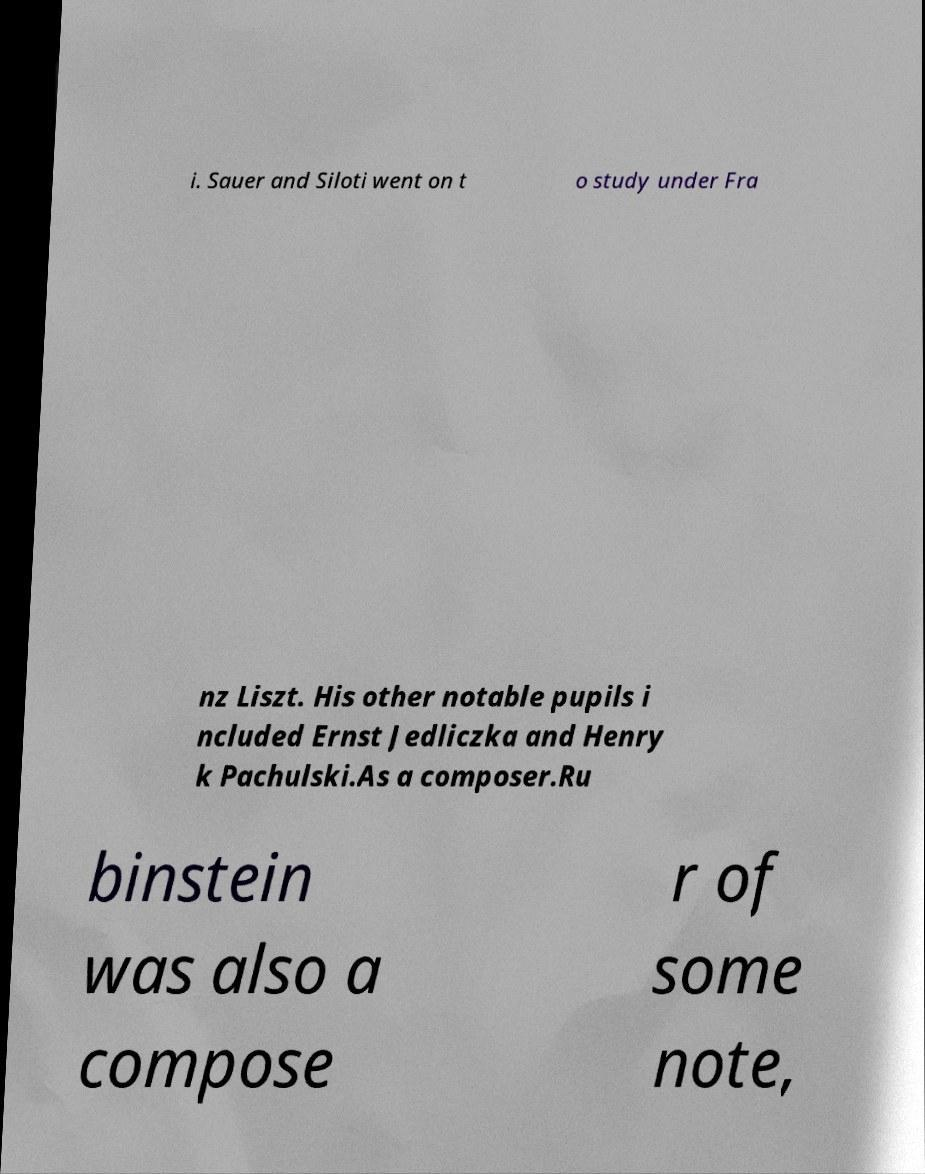Can you accurately transcribe the text from the provided image for me? i. Sauer and Siloti went on t o study under Fra nz Liszt. His other notable pupils i ncluded Ernst Jedliczka and Henry k Pachulski.As a composer.Ru binstein was also a compose r of some note, 